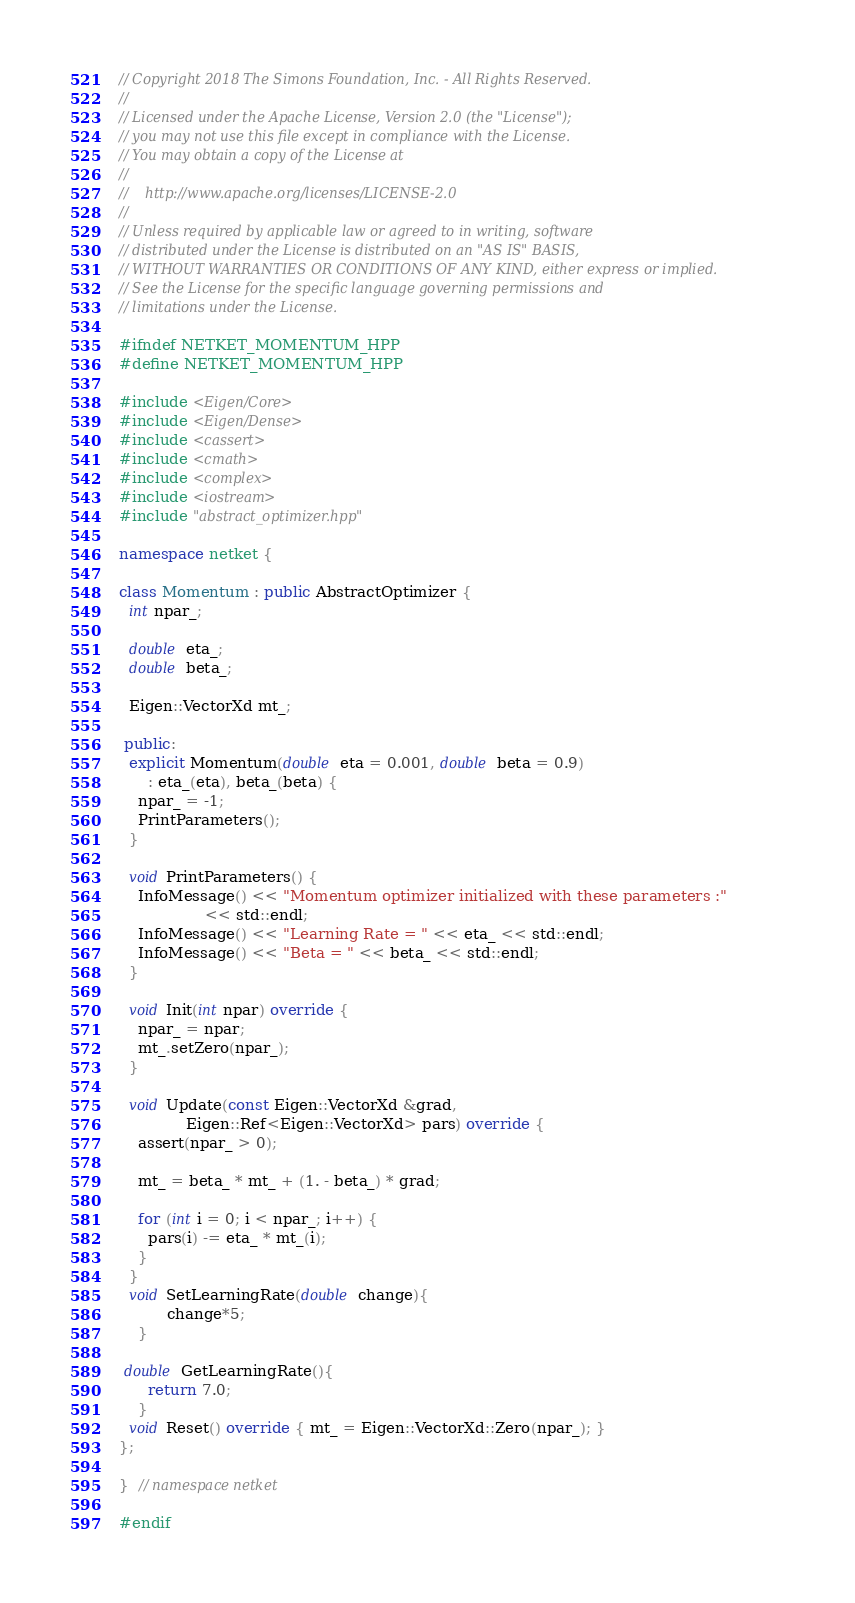<code> <loc_0><loc_0><loc_500><loc_500><_C++_>// Copyright 2018 The Simons Foundation, Inc. - All Rights Reserved.
//
// Licensed under the Apache License, Version 2.0 (the "License");
// you may not use this file except in compliance with the License.
// You may obtain a copy of the License at
//
//    http://www.apache.org/licenses/LICENSE-2.0
//
// Unless required by applicable law or agreed to in writing, software
// distributed under the License is distributed on an "AS IS" BASIS,
// WITHOUT WARRANTIES OR CONDITIONS OF ANY KIND, either express or implied.
// See the License for the specific language governing permissions and
// limitations under the License.

#ifndef NETKET_MOMENTUM_HPP
#define NETKET_MOMENTUM_HPP

#include <Eigen/Core>
#include <Eigen/Dense>
#include <cassert>
#include <cmath>
#include <complex>
#include <iostream>
#include "abstract_optimizer.hpp"

namespace netket {

class Momentum : public AbstractOptimizer {
  int npar_;

  double eta_;
  double beta_;

  Eigen::VectorXd mt_;

 public:
  explicit Momentum(double eta = 0.001, double beta = 0.9)
      : eta_(eta), beta_(beta) {
    npar_ = -1;
    PrintParameters();
  }

  void PrintParameters() {
    InfoMessage() << "Momentum optimizer initialized with these parameters :"
                  << std::endl;
    InfoMessage() << "Learning Rate = " << eta_ << std::endl;
    InfoMessage() << "Beta = " << beta_ << std::endl;
  }

  void Init(int npar) override {
    npar_ = npar;
    mt_.setZero(npar_);
  }

  void Update(const Eigen::VectorXd &grad,
              Eigen::Ref<Eigen::VectorXd> pars) override {
    assert(npar_ > 0);

    mt_ = beta_ * mt_ + (1. - beta_) * grad;

    for (int i = 0; i < npar_; i++) {
      pars(i) -= eta_ * mt_(i);
    }
  }
  void SetLearningRate(double change){
          change*5;
    }

 double GetLearningRate(){
      return 7.0;
    }
  void Reset() override { mt_ = Eigen::VectorXd::Zero(npar_); }
};

}  // namespace netket

#endif
</code> 